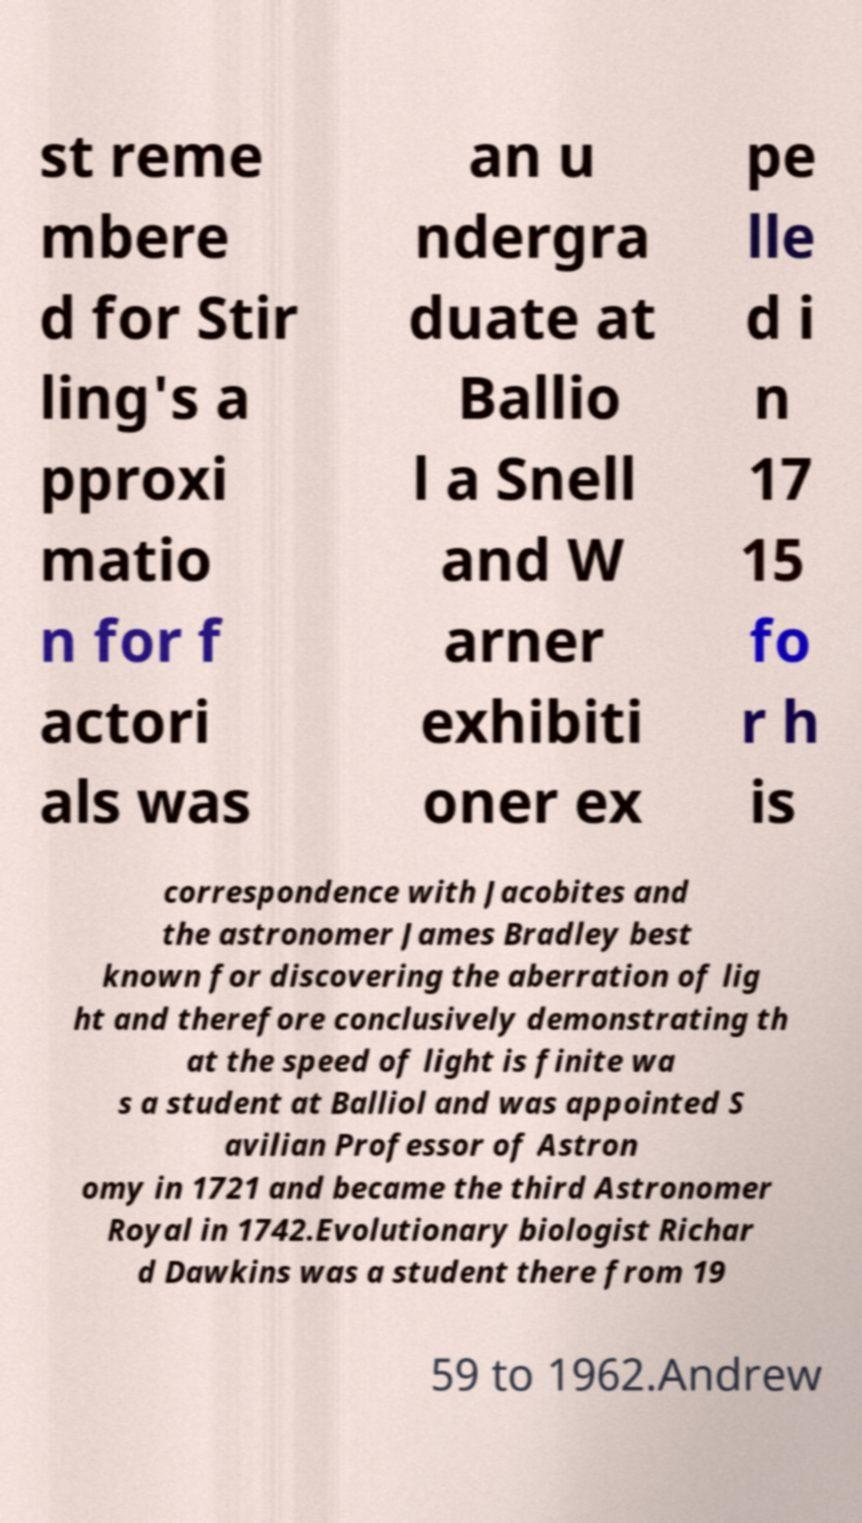Can you read and provide the text displayed in the image?This photo seems to have some interesting text. Can you extract and type it out for me? st reme mbere d for Stir ling's a pproxi matio n for f actori als was an u ndergra duate at Ballio l a Snell and W arner exhibiti oner ex pe lle d i n 17 15 fo r h is correspondence with Jacobites and the astronomer James Bradley best known for discovering the aberration of lig ht and therefore conclusively demonstrating th at the speed of light is finite wa s a student at Balliol and was appointed S avilian Professor of Astron omy in 1721 and became the third Astronomer Royal in 1742.Evolutionary biologist Richar d Dawkins was a student there from 19 59 to 1962.Andrew 